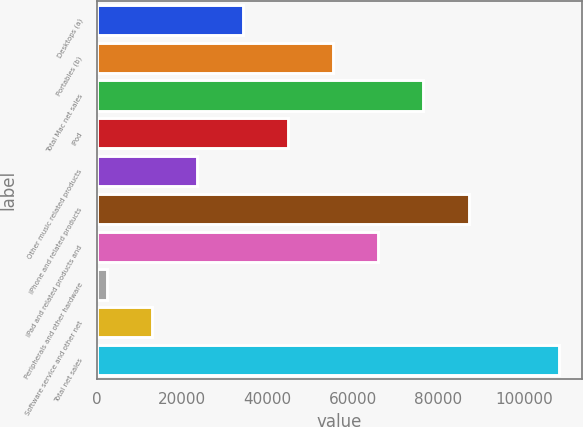<chart> <loc_0><loc_0><loc_500><loc_500><bar_chart><fcel>Desktops (a)<fcel>Portables (b)<fcel>Total Mac net sales<fcel>iPod<fcel>Other music related products<fcel>iPhone and related products<fcel>iPad and related products and<fcel>Peripherals and other hardware<fcel>Software service and other net<fcel>Total net sales<nl><fcel>34105.7<fcel>55289.5<fcel>76473.3<fcel>44697.6<fcel>23513.8<fcel>87065.2<fcel>65881.4<fcel>2330<fcel>12921.9<fcel>108249<nl></chart> 